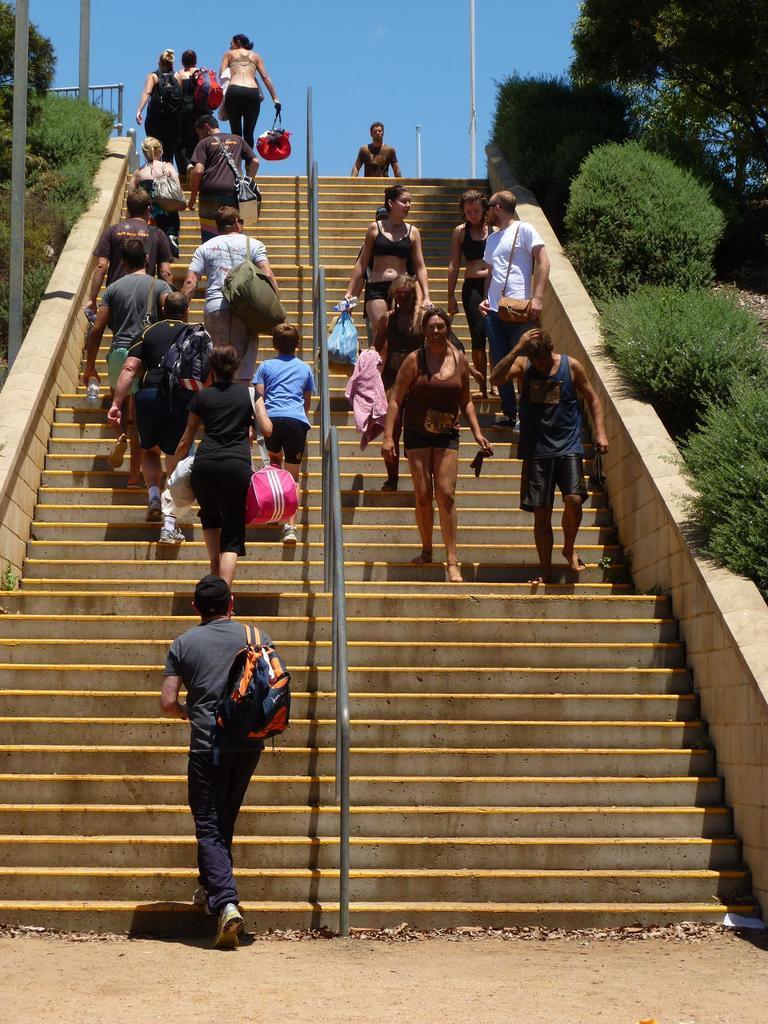Could you give a brief overview of what you see in this image? In this image we can see a group of people are standing on the staircase, there is a metal rod, beside there are trees, there are poles, there is sky at the top. 